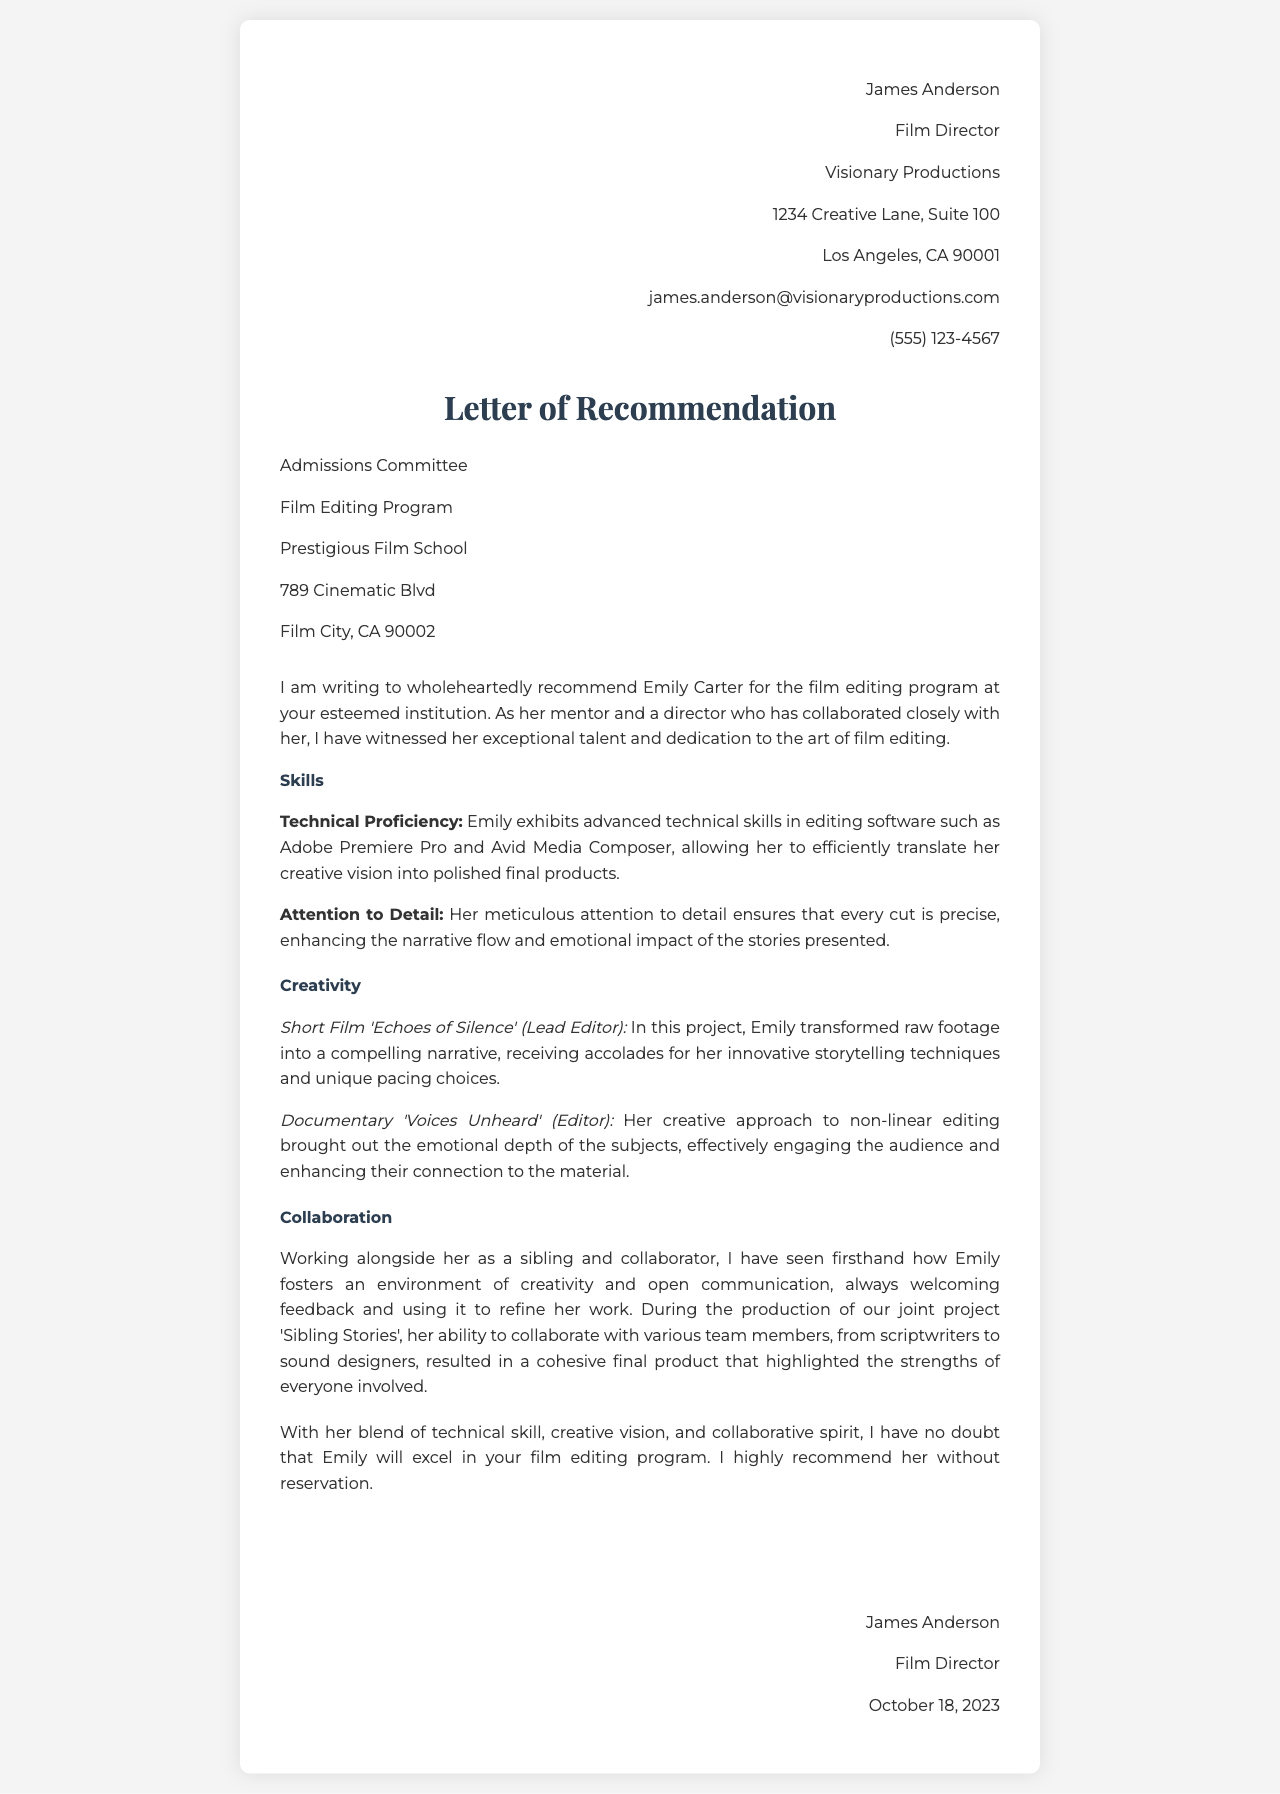What is the name of the person being recommended? The letter recommends Emily Carter for the film editing program.
Answer: Emily Carter Who wrote the letter of recommendation? The author of the letter is James Anderson, who is also a film director.
Answer: James Anderson What is the title of the project Emily was lead editor on? The project where Emily was the lead editor is titled 'Echoes of Silence'.
Answer: Echoes of Silence Which software is mentioned as Emily's technical proficiency? The letter specifies that Emily has advanced skills in Adobe Premiere Pro and Avid Media Composer.
Answer: Adobe Premiere Pro and Avid Media Composer What is one of Emily's key strengths highlighted in the letter? The letter highlights her meticulous attention to detail as a key strength, ensuring precise cuts.
Answer: Attention to Detail What type of editing style did Emily utilize in the documentary 'Voices Unheard'? Emily's editing in the documentary is described as non-linear, which effectively engaged the audience.
Answer: Non-linear editing What is the relationship between Emily and the letter writer? The letter states that Emily and James Anderson are siblings and collaborators.
Answer: Siblings What is the date on which the letter was written? The letter is dated October 18, 2023.
Answer: October 18, 2023 Who is the letter addressed to? The letter is addressed to the Admissions Committee of the Film Editing Program at a prestigious film school.
Answer: Admissions Committee 